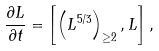Convert formula to latex. <formula><loc_0><loc_0><loc_500><loc_500>\frac { \partial L } { \partial t } = \left [ \left ( L ^ { 5 / 3 } \right ) _ { \geq 2 } , L \right ] ,</formula> 